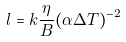<formula> <loc_0><loc_0><loc_500><loc_500>l = k \frac { \eta } { B } ( \alpha \Delta T ) ^ { - 2 }</formula> 